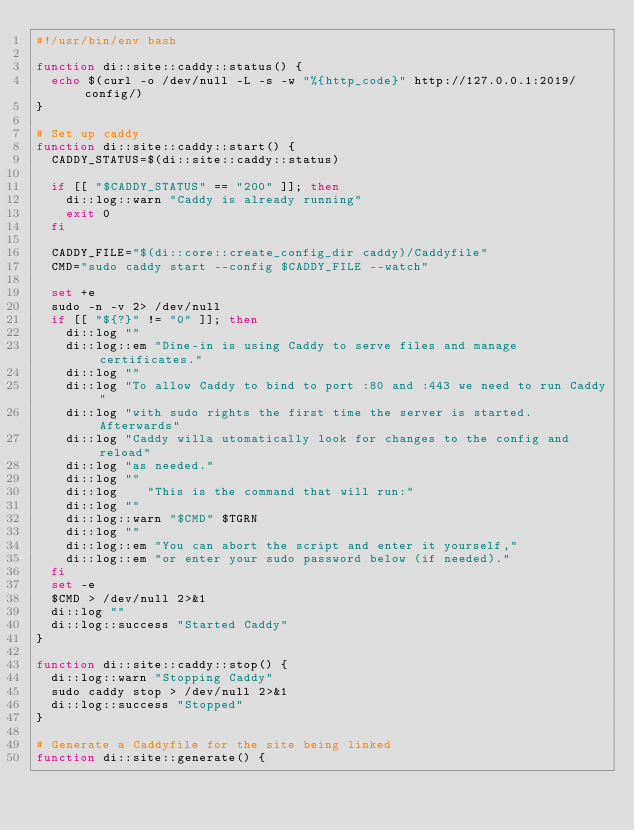<code> <loc_0><loc_0><loc_500><loc_500><_Bash_>#!/usr/bin/env bash

function di::site::caddy::status() {
	echo $(curl -o /dev/null -L -s -w "%{http_code}" http://127.0.0.1:2019/config/)
}

# Set up caddy
function di::site::caddy::start() {
	CADDY_STATUS=$(di::site::caddy::status)

	if [[ "$CADDY_STATUS" == "200" ]]; then
		di::log::warn "Caddy is already running"
		exit 0
	fi

	CADDY_FILE="$(di::core::create_config_dir caddy)/Caddyfile"
	CMD="sudo caddy start --config $CADDY_FILE --watch"

	set +e
	sudo -n -v 2> /dev/null
	if [[ "${?}" != "0" ]]; then
		di::log ""
		di::log::em "Dine-in is using Caddy to serve files and manage certificates."
		di::log ""
		di::log "To allow Caddy to bind to port :80 and :443 we need to run Caddy"
		di::log "with sudo rights the first time the server is started. Afterwards"
		di::log "Caddy willa utomatically look for changes to the config and reload"
		di::log "as needed."
		di::log ""
		di::log    "This is the command that will run:"
		di::log ""
		di::log::warn "$CMD" $TGRN
		di::log ""
		di::log::em "You can abort the script and enter it yourself,"
		di::log::em "or enter your sudo password below (if needed)."
	fi
	set -e
	$CMD > /dev/null 2>&1
	di::log ""
	di::log::success "Started Caddy"
}

function di::site::caddy::stop() {
	di::log::warn "Stopping Caddy"
	sudo caddy stop > /dev/null 2>&1
	di::log::success "Stopped"
}

# Generate a Caddyfile for the site being linked
function di::site::generate() {</code> 